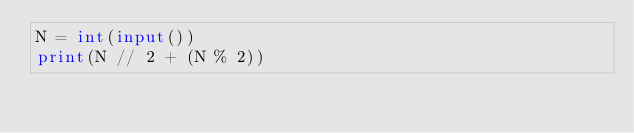<code> <loc_0><loc_0><loc_500><loc_500><_Python_>N = int(input())
print(N // 2 + (N % 2))</code> 